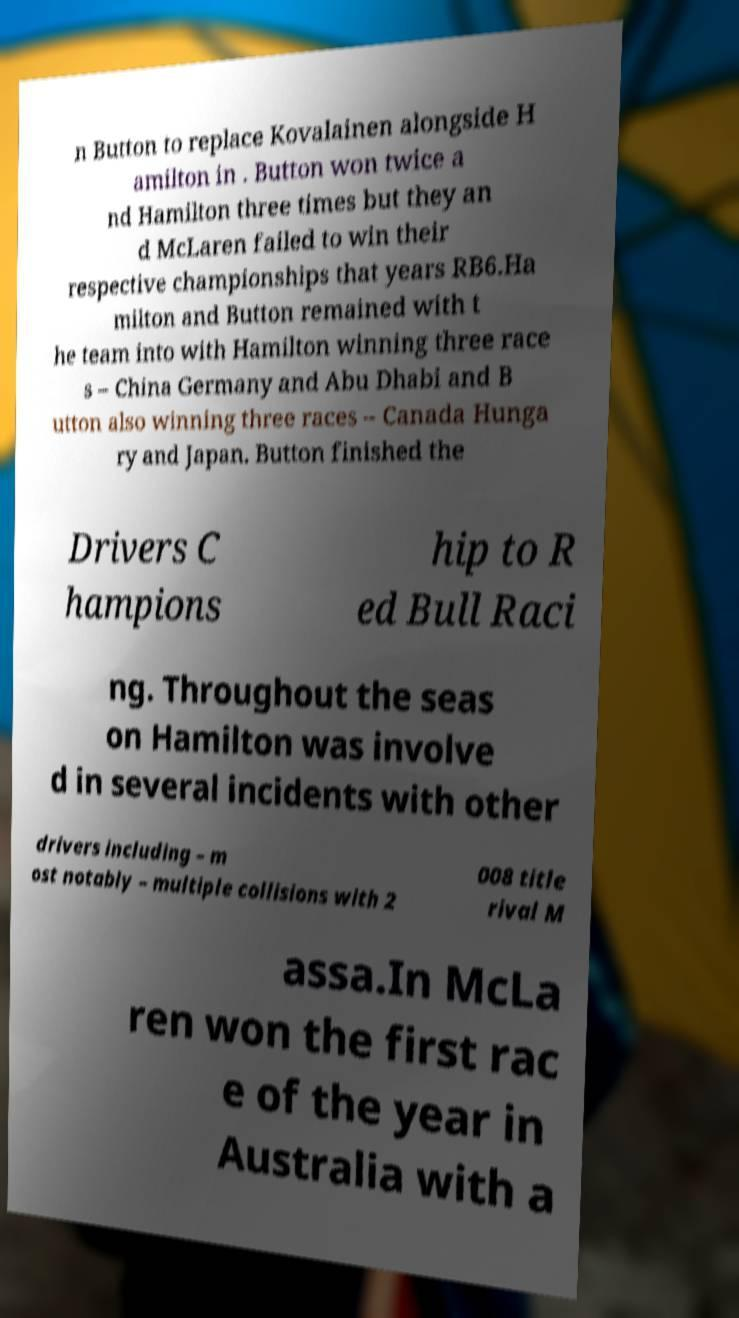I need the written content from this picture converted into text. Can you do that? n Button to replace Kovalainen alongside H amilton in . Button won twice a nd Hamilton three times but they an d McLaren failed to win their respective championships that years RB6.Ha milton and Button remained with t he team into with Hamilton winning three race s – China Germany and Abu Dhabi and B utton also winning three races – Canada Hunga ry and Japan. Button finished the Drivers C hampions hip to R ed Bull Raci ng. Throughout the seas on Hamilton was involve d in several incidents with other drivers including – m ost notably – multiple collisions with 2 008 title rival M assa.In McLa ren won the first rac e of the year in Australia with a 